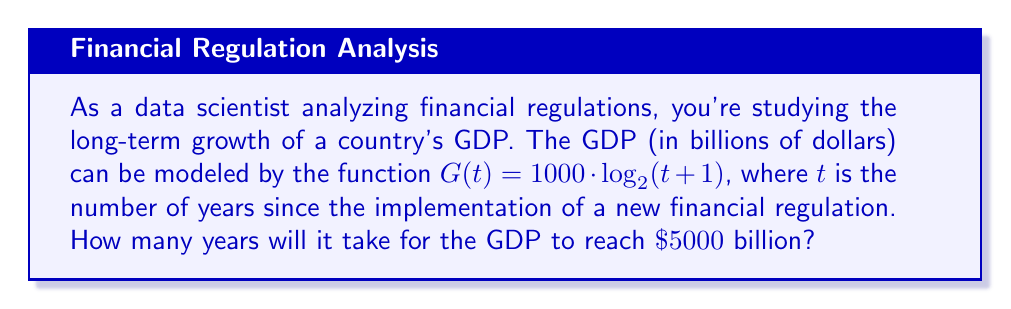Teach me how to tackle this problem. Let's approach this step-by-step:

1) We need to solve the equation:
   $G(t) = 5000$

2) Substituting the given function:
   $1000 \cdot \log_2(t+1) = 5000$

3) Divide both sides by 1000:
   $\log_2(t+1) = 5$

4) To solve for $t$, we need to apply the inverse function (exponential) to both sides:
   $2^{\log_2(t+1)} = 2^5$

5) The left side simplifies to $(t+1)$:
   $t + 1 = 2^5 = 32$

6) Subtract 1 from both sides:
   $t = 31$

Therefore, it will take 31 years for the GDP to reach $5000 billion after the implementation of the new financial regulation.
Answer: 31 years 